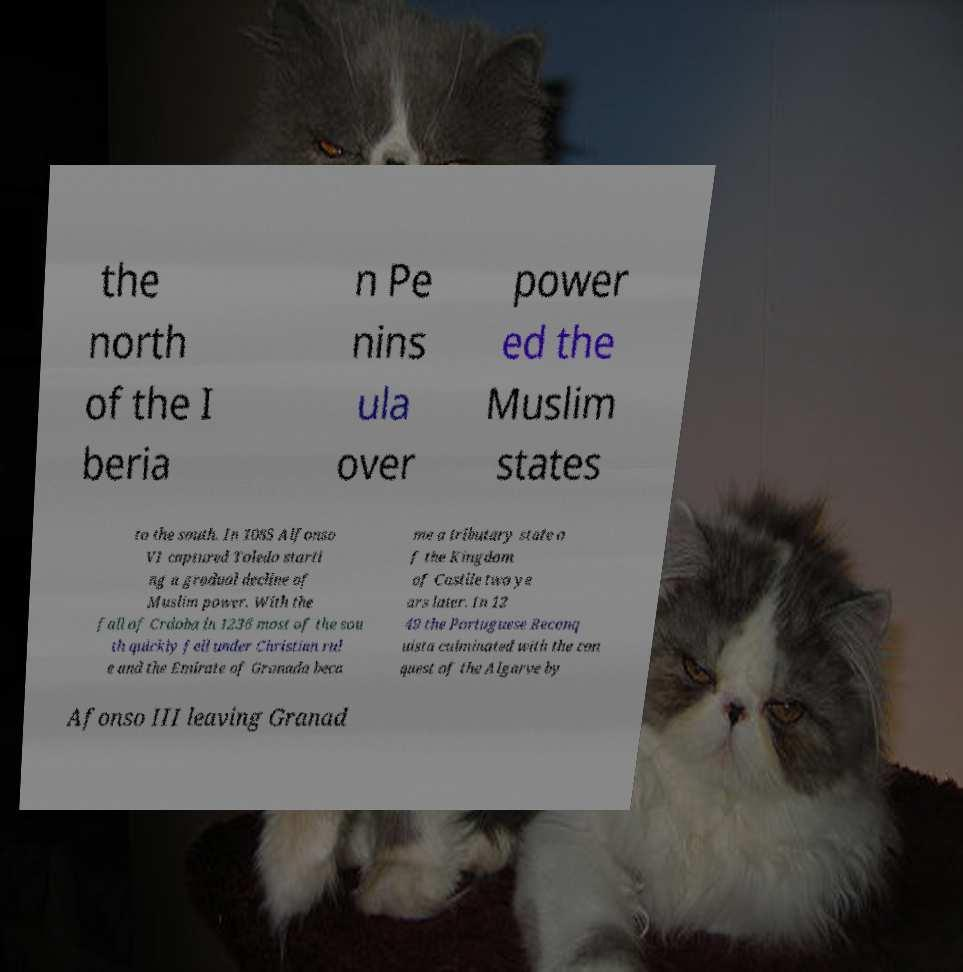For documentation purposes, I need the text within this image transcribed. Could you provide that? the north of the I beria n Pe nins ula over power ed the Muslim states to the south. In 1085 Alfonso VI captured Toledo starti ng a gradual decline of Muslim power. With the fall of Crdoba in 1236 most of the sou th quickly fell under Christian rul e and the Emirate of Granada beca me a tributary state o f the Kingdom of Castile two ye ars later. In 12 49 the Portuguese Reconq uista culminated with the con quest of the Algarve by Afonso III leaving Granad 